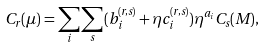<formula> <loc_0><loc_0><loc_500><loc_500>C _ { r } ( \mu ) = \sum _ { i } \sum _ { s } ( b _ { i } ^ { ( r , s ) } + \eta c _ { i } ^ { ( r , s ) } ) \eta ^ { a _ { i } } C _ { s } ( M ) ,</formula> 